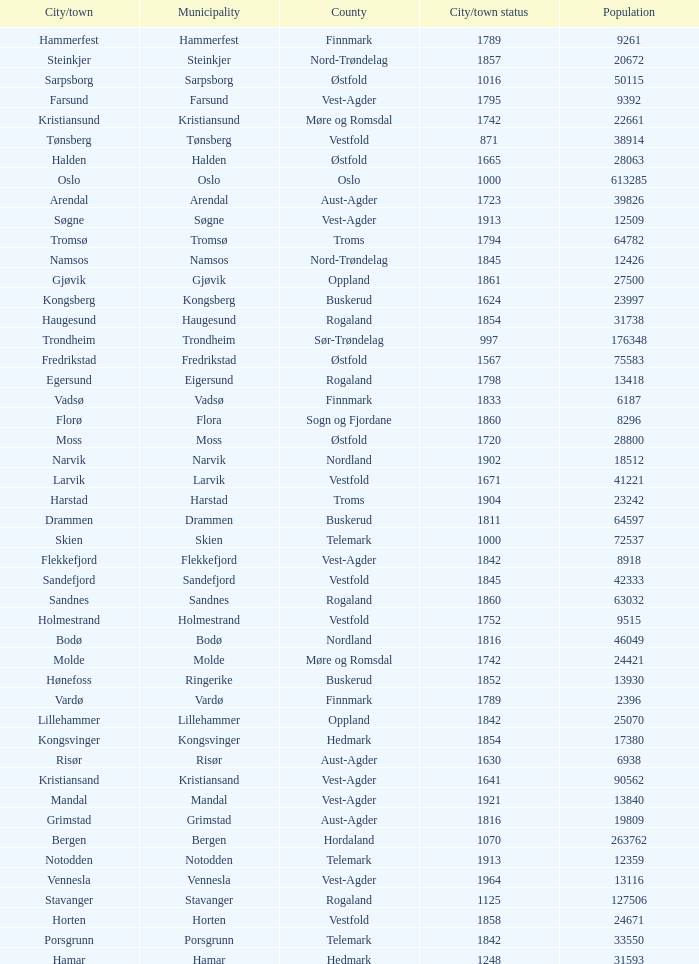Which municipalities located in the county of Finnmark have populations bigger than 6187.0? Hammerfest. Write the full table. {'header': ['City/town', 'Municipality', 'County', 'City/town status', 'Population'], 'rows': [['Hammerfest', 'Hammerfest', 'Finnmark', '1789', '9261'], ['Steinkjer', 'Steinkjer', 'Nord-Trøndelag', '1857', '20672'], ['Sarpsborg', 'Sarpsborg', 'Østfold', '1016', '50115'], ['Farsund', 'Farsund', 'Vest-Agder', '1795', '9392'], ['Kristiansund', 'Kristiansund', 'Møre og Romsdal', '1742', '22661'], ['Tønsberg', 'Tønsberg', 'Vestfold', '871', '38914'], ['Halden', 'Halden', 'Østfold', '1665', '28063'], ['Oslo', 'Oslo', 'Oslo', '1000', '613285'], ['Arendal', 'Arendal', 'Aust-Agder', '1723', '39826'], ['Søgne', 'Søgne', 'Vest-Agder', '1913', '12509'], ['Tromsø', 'Tromsø', 'Troms', '1794', '64782'], ['Namsos', 'Namsos', 'Nord-Trøndelag', '1845', '12426'], ['Gjøvik', 'Gjøvik', 'Oppland', '1861', '27500'], ['Kongsberg', 'Kongsberg', 'Buskerud', '1624', '23997'], ['Haugesund', 'Haugesund', 'Rogaland', '1854', '31738'], ['Trondheim', 'Trondheim', 'Sør-Trøndelag', '997', '176348'], ['Fredrikstad', 'Fredrikstad', 'Østfold', '1567', '75583'], ['Egersund', 'Eigersund', 'Rogaland', '1798', '13418'], ['Vadsø', 'Vadsø', 'Finnmark', '1833', '6187'], ['Florø', 'Flora', 'Sogn og Fjordane', '1860', '8296'], ['Moss', 'Moss', 'Østfold', '1720', '28800'], ['Narvik', 'Narvik', 'Nordland', '1902', '18512'], ['Larvik', 'Larvik', 'Vestfold', '1671', '41221'], ['Harstad', 'Harstad', 'Troms', '1904', '23242'], ['Drammen', 'Drammen', 'Buskerud', '1811', '64597'], ['Skien', 'Skien', 'Telemark', '1000', '72537'], ['Flekkefjord', 'Flekkefjord', 'Vest-Agder', '1842', '8918'], ['Sandefjord', 'Sandefjord', 'Vestfold', '1845', '42333'], ['Sandnes', 'Sandnes', 'Rogaland', '1860', '63032'], ['Holmestrand', 'Holmestrand', 'Vestfold', '1752', '9515'], ['Bodø', 'Bodø', 'Nordland', '1816', '46049'], ['Molde', 'Molde', 'Møre og Romsdal', '1742', '24421'], ['Hønefoss', 'Ringerike', 'Buskerud', '1852', '13930'], ['Vardø', 'Vardø', 'Finnmark', '1789', '2396'], ['Lillehammer', 'Lillehammer', 'Oppland', '1842', '25070'], ['Kongsvinger', 'Kongsvinger', 'Hedmark', '1854', '17380'], ['Risør', 'Risør', 'Aust-Agder', '1630', '6938'], ['Kristiansand', 'Kristiansand', 'Vest-Agder', '1641', '90562'], ['Mandal', 'Mandal', 'Vest-Agder', '1921', '13840'], ['Grimstad', 'Grimstad', 'Aust-Agder', '1816', '19809'], ['Bergen', 'Bergen', 'Hordaland', '1070', '263762'], ['Notodden', 'Notodden', 'Telemark', '1913', '12359'], ['Vennesla', 'Vennesla', 'Vest-Agder', '1964', '13116'], ['Stavanger', 'Stavanger', 'Rogaland', '1125', '127506'], ['Horten', 'Horten', 'Vestfold', '1858', '24671'], ['Porsgrunn', 'Porsgrunn', 'Telemark', '1842', '33550'], ['Hamar', 'Hamar', 'Hedmark', '1248', '31593']]} 